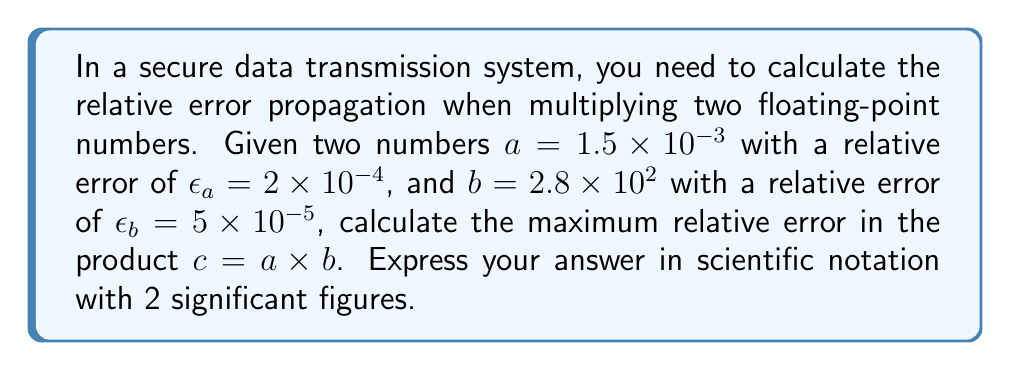Show me your answer to this math problem. To calculate the maximum relative error in the product of two floating-point numbers, we follow these steps:

1) The formula for the maximum relative error in a product is:

   $$\epsilon_c \approx |\epsilon_a| + |\epsilon_b|$$

   Where $\epsilon_c$ is the relative error in the product, and $\epsilon_a$ and $\epsilon_b$ are the relative errors in the factors.

2) We are given:
   $\epsilon_a = 2 \times 10^{-4}$
   $\epsilon_b = 5 \times 10^{-5}$

3) Substituting these values into the formula:

   $$\epsilon_c \approx |2 \times 10^{-4}| + |5 \times 10^{-5}|$$

4) Simplify:
   $$\epsilon_c \approx 2 \times 10^{-4} + 5 \times 10^{-5}$$

5) To add these, we need to convert $5 \times 10^{-5}$ to the same exponent as $2 \times 10^{-4}$:
   $$\epsilon_c \approx 2 \times 10^{-4} + 0.5 \times 10^{-4}$$

6) Add:
   $$\epsilon_c \approx 2.5 \times 10^{-4}$$

7) This is already in scientific notation with 2 significant figures, so no further adjustment is needed.
Answer: $2.5 \times 10^{-4}$ 